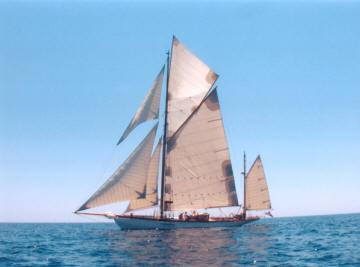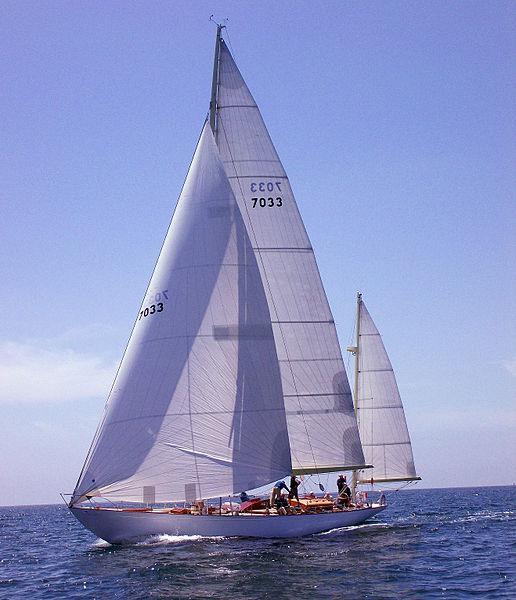The first image is the image on the left, the second image is the image on the right. For the images shown, is this caption "Exactly two people are visible and seated in a boat with a wood interior." true? Answer yes or no. No. The first image is the image on the left, the second image is the image on the right. Assess this claim about the two images: "There is a person in a red coat in one of the images". Correct or not? Answer yes or no. No. 